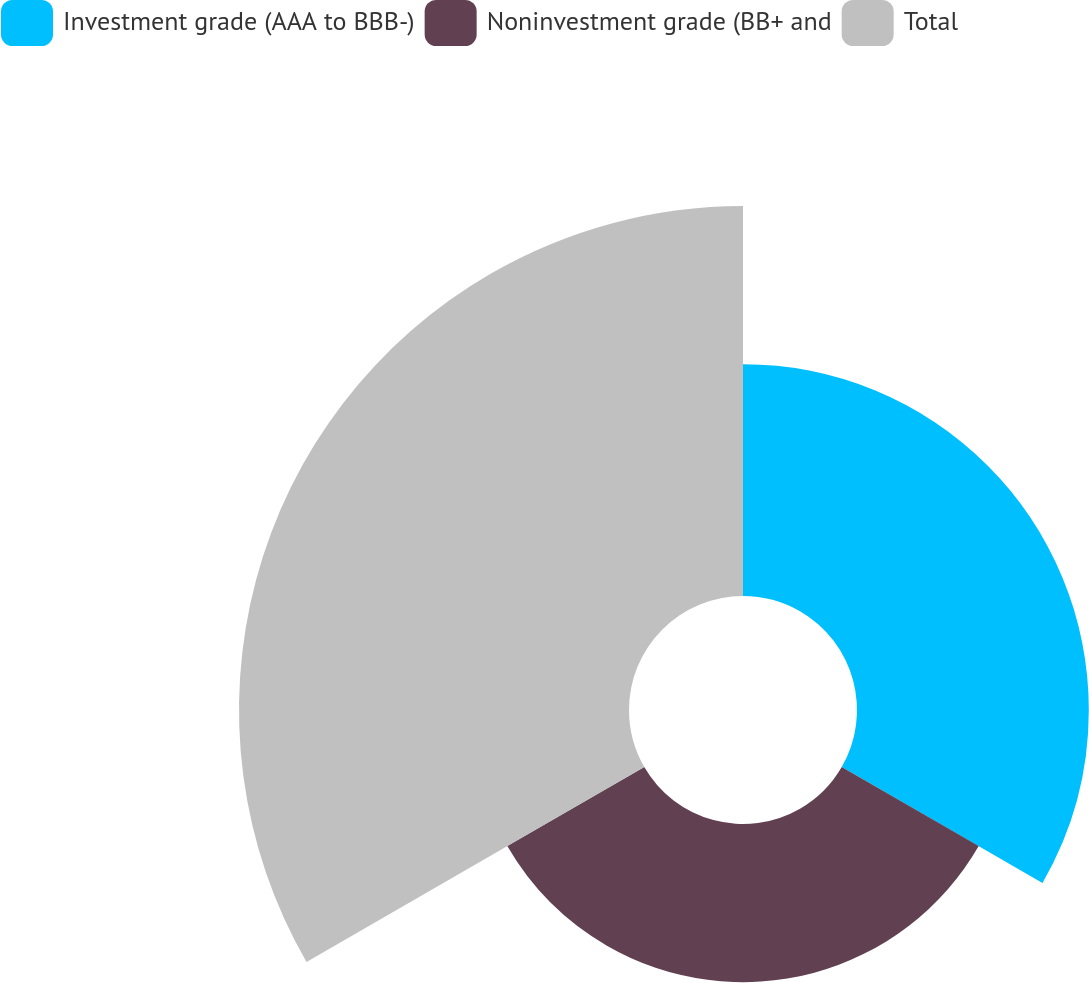Convert chart. <chart><loc_0><loc_0><loc_500><loc_500><pie_chart><fcel>Investment grade (AAA to BBB-)<fcel>Noninvestment grade (BB+ and<fcel>Total<nl><fcel>29.72%<fcel>20.28%<fcel>50.0%<nl></chart> 